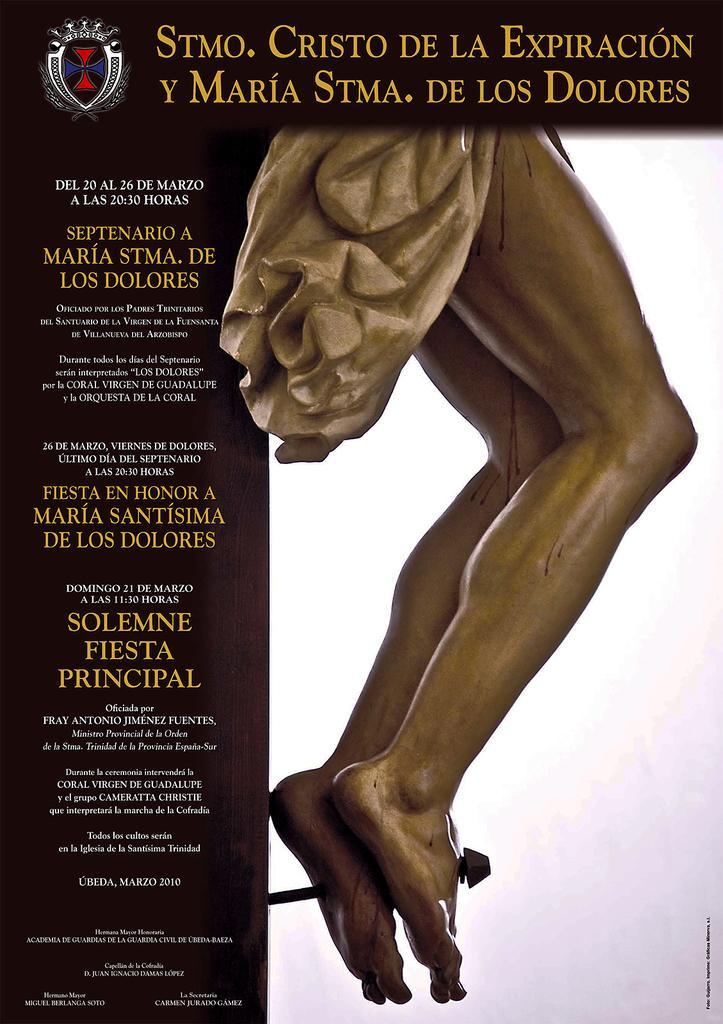Please provide a concise description of this image. This is an article and here we can see an image of a statue and there is some text. 